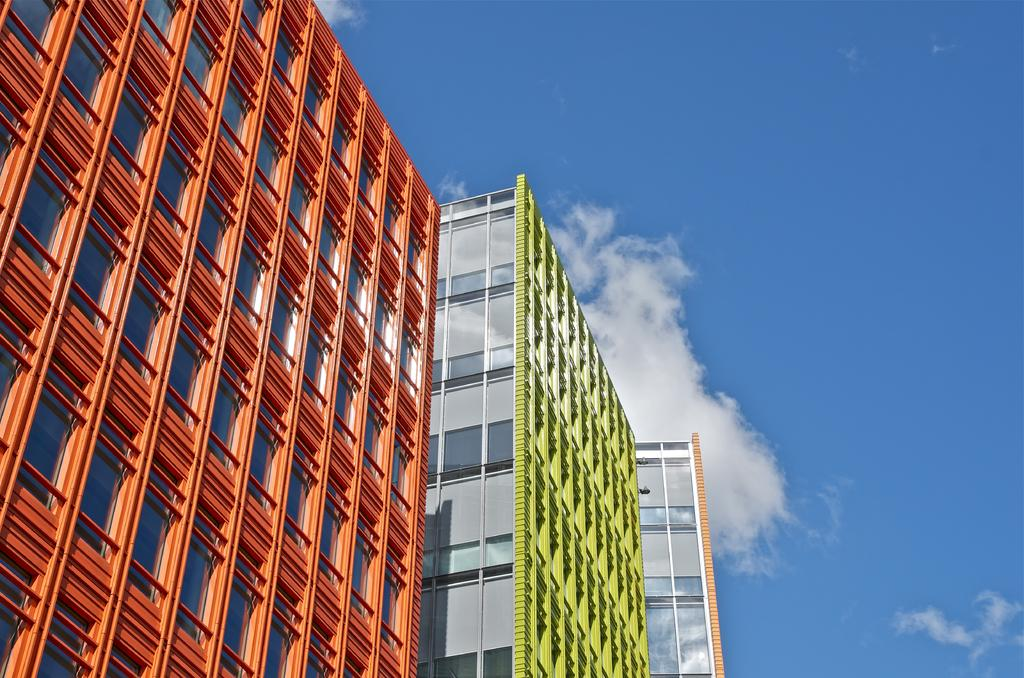What is located in the foreground of the image? There are buildings in the foreground of the image. What can be seen in the background of the image? The sky is visible in the image. What is the condition of the sky in the image? Clouds are present in the sky. What type of rice can be seen growing in the image? There is no rice present in the image, and therefore no growth can be observed. 